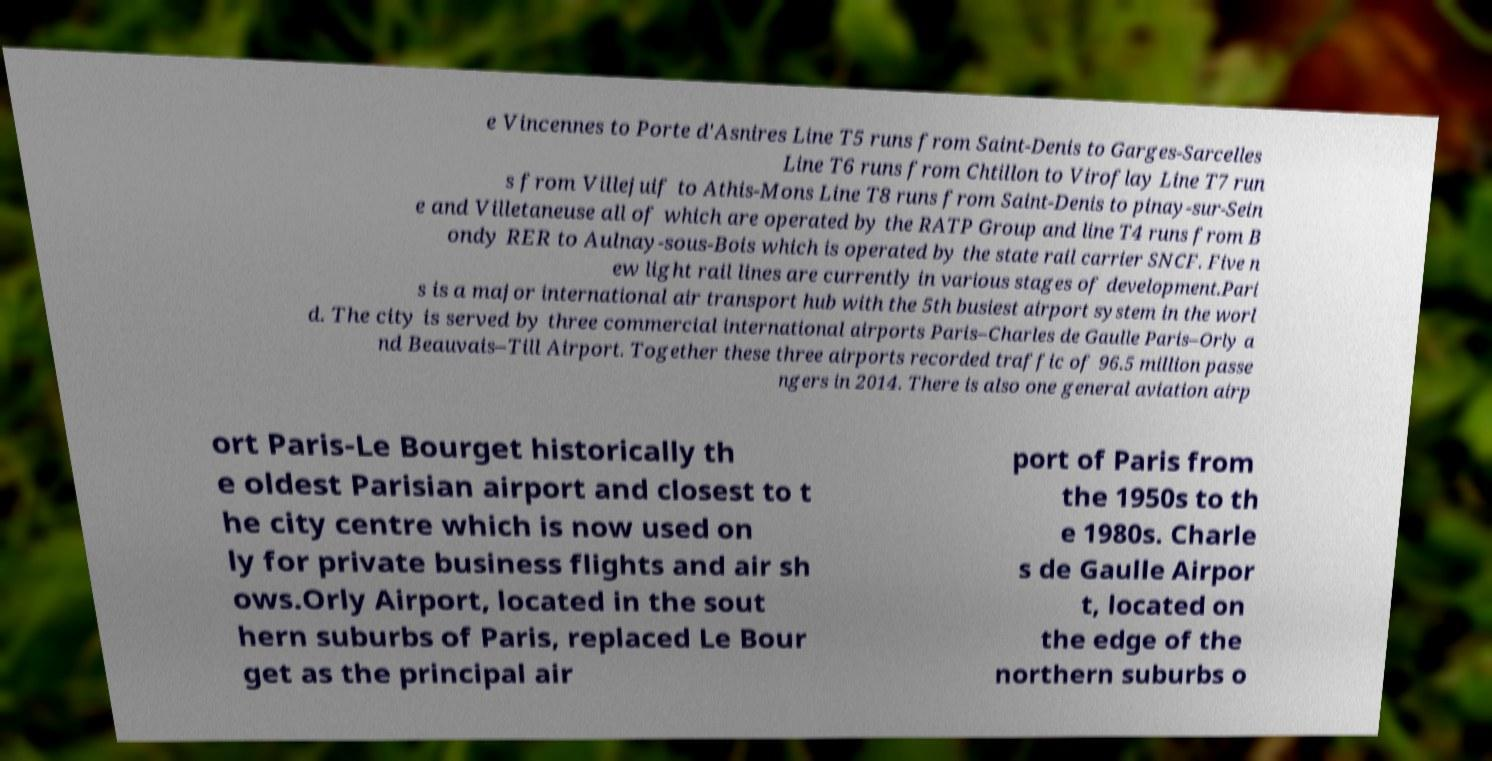What messages or text are displayed in this image? I need them in a readable, typed format. e Vincennes to Porte d'Asnires Line T5 runs from Saint-Denis to Garges-Sarcelles Line T6 runs from Chtillon to Viroflay Line T7 run s from Villejuif to Athis-Mons Line T8 runs from Saint-Denis to pinay-sur-Sein e and Villetaneuse all of which are operated by the RATP Group and line T4 runs from B ondy RER to Aulnay-sous-Bois which is operated by the state rail carrier SNCF. Five n ew light rail lines are currently in various stages of development.Pari s is a major international air transport hub with the 5th busiest airport system in the worl d. The city is served by three commercial international airports Paris–Charles de Gaulle Paris–Orly a nd Beauvais–Till Airport. Together these three airports recorded traffic of 96.5 million passe ngers in 2014. There is also one general aviation airp ort Paris-Le Bourget historically th e oldest Parisian airport and closest to t he city centre which is now used on ly for private business flights and air sh ows.Orly Airport, located in the sout hern suburbs of Paris, replaced Le Bour get as the principal air port of Paris from the 1950s to th e 1980s. Charle s de Gaulle Airpor t, located on the edge of the northern suburbs o 